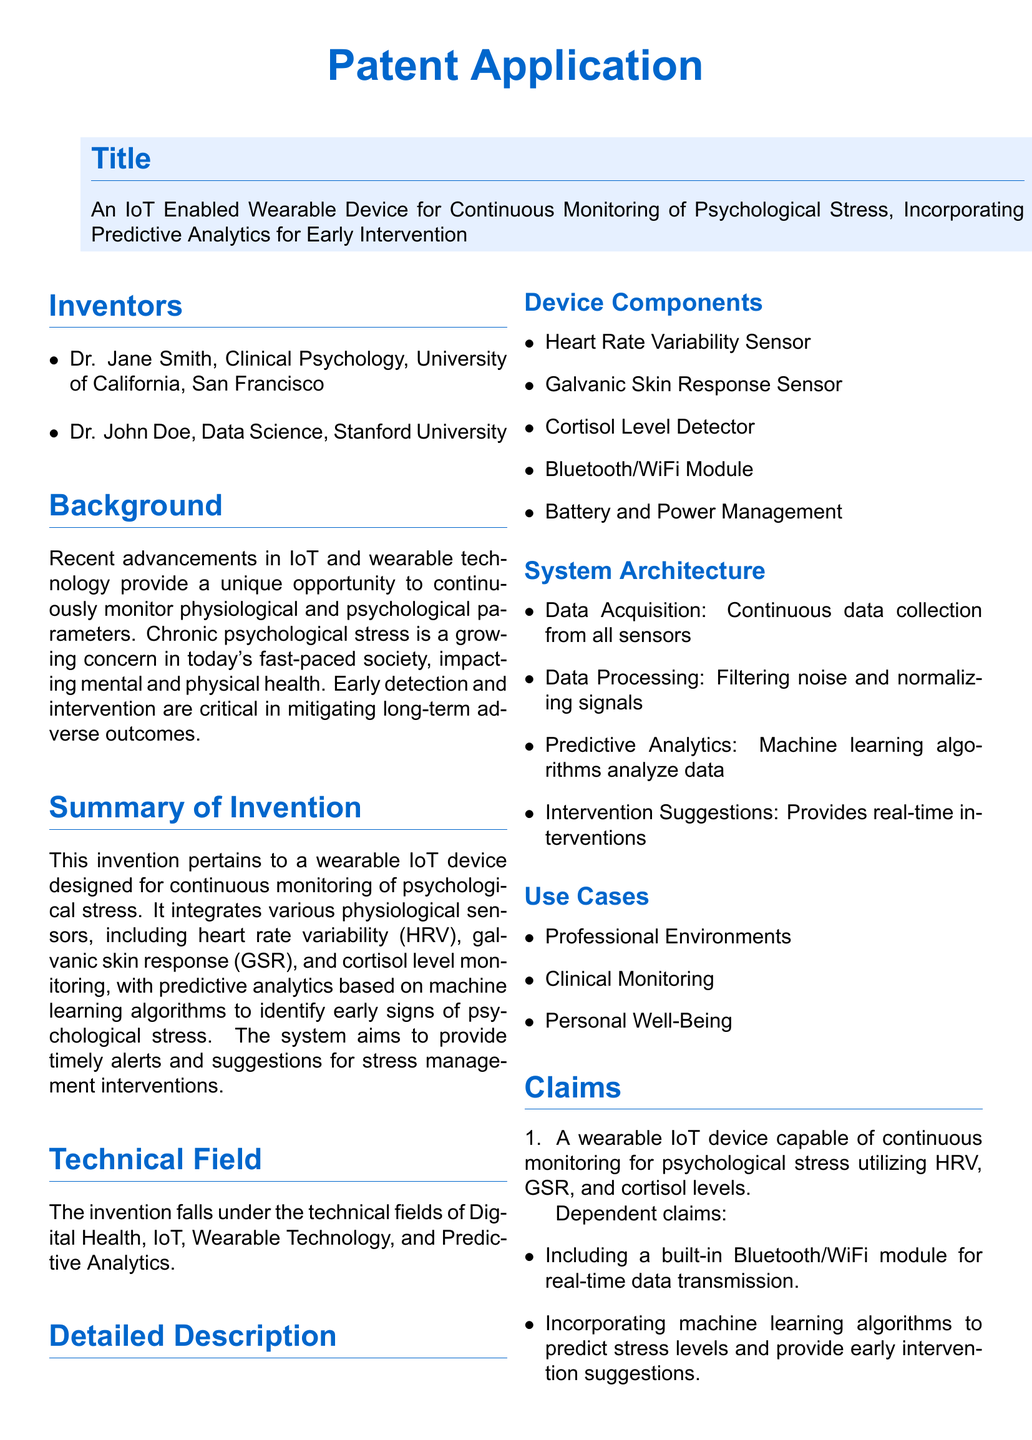What is the title of the invention? The title is explicitly mentioned at the beginning of the document.
Answer: An IoT Enabled Wearable Device for Continuous Monitoring of Psychological Stress, Incorporating Predictive Analytics for Early Intervention Who are the inventors? The names of the inventors are listed in the "Inventors" section of the document.
Answer: Dr. Jane Smith, Dr. John Doe What are the physiological sensors integrated into the device? The document lists the sensors under "Device Components".
Answer: Heart Rate Variability Sensor, Galvanic Skin Response Sensor, Cortisol Level Detector What is the purpose of predictive analytics in the device? The summary explains the role of predictive analytics regarding stress monitoring.
Answer: To identify early signs of psychological stress What type of environments is the device designed for? The use cases mentioned provide insights into the intended environments for the device.
Answer: Professional Environments, Clinical Monitoring, Personal Well-Being What is the claim about the device's capability? The primary claim in the document states the main functionality of the device.
Answer: A wearable IoT device capable of continuous monitoring for psychological stress How does the device provide interventions? The detailed description explains the system architecture related to interventions.
Answer: Provides real-time interventions Which institution is Dr. Jane Smith affiliated with? The document provides information regarding the affiliations of the inventors.
Answer: University of California, San Francisco What technical fields does the invention fall under? The document specifies the technical fields in the corresponding section.
Answer: Digital Health, IoT, Wearable Technology, Predictive Analytics 